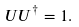Convert formula to latex. <formula><loc_0><loc_0><loc_500><loc_500>U U ^ { \dagger } = 1 .</formula> 